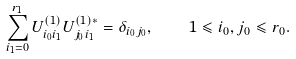<formula> <loc_0><loc_0><loc_500><loc_500>\sum _ { i _ { 1 } = 0 } ^ { r _ { 1 } } U _ { i _ { 0 } i _ { 1 } } ^ { \left ( 1 \right ) } U _ { j _ { 0 } i _ { 1 } } ^ { \left ( 1 \right ) \ast } = \delta _ { i _ { 0 } j _ { 0 } } , \quad 1 \leqslant i _ { 0 } , j _ { 0 } \leqslant r _ { 0 } .</formula> 